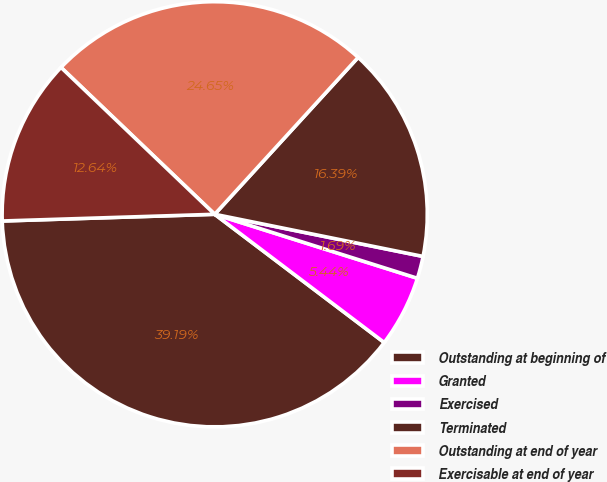Convert chart. <chart><loc_0><loc_0><loc_500><loc_500><pie_chart><fcel>Outstanding at beginning of<fcel>Granted<fcel>Exercised<fcel>Terminated<fcel>Outstanding at end of year<fcel>Exercisable at end of year<nl><fcel>39.19%<fcel>5.44%<fcel>1.69%<fcel>16.39%<fcel>24.65%<fcel>12.64%<nl></chart> 